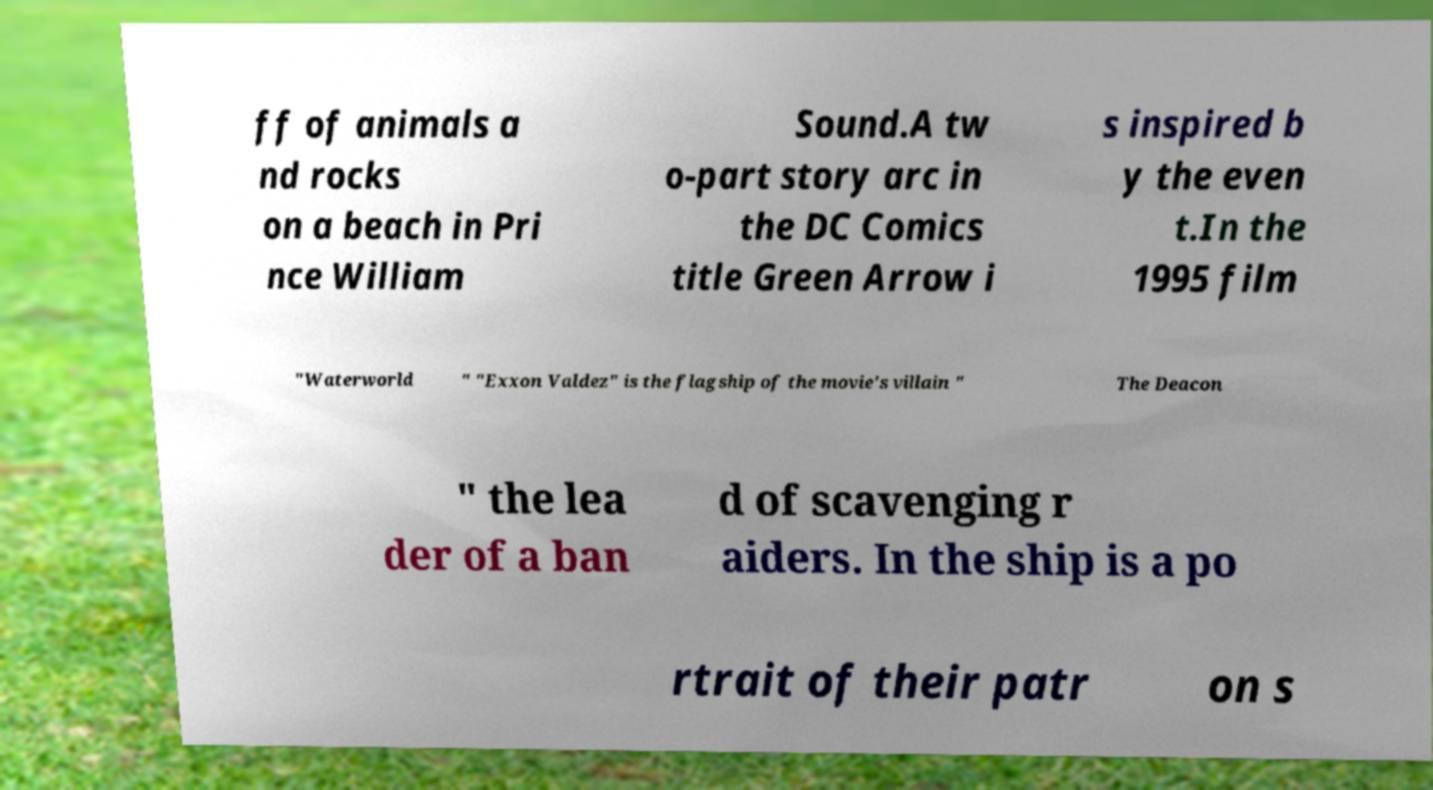Please read and relay the text visible in this image. What does it say? ff of animals a nd rocks on a beach in Pri nce William Sound.A tw o-part story arc in the DC Comics title Green Arrow i s inspired b y the even t.In the 1995 film "Waterworld " "Exxon Valdez" is the flagship of the movie's villain " The Deacon " the lea der of a ban d of scavenging r aiders. In the ship is a po rtrait of their patr on s 